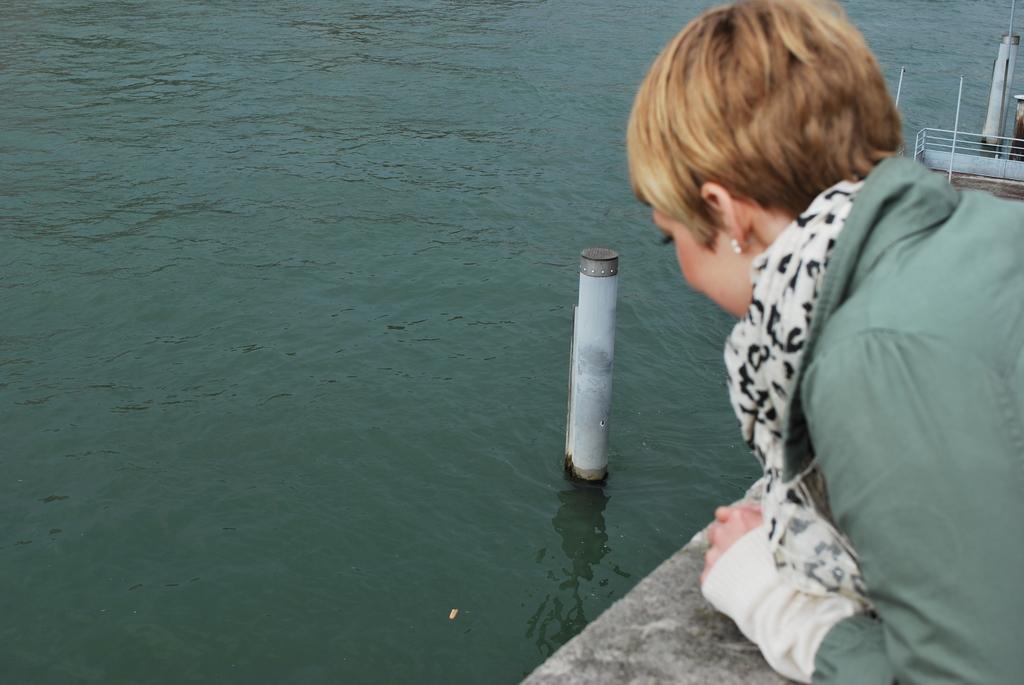How would you summarize this image in a sentence or two? In this image on the right side there is one woman who is standing, and at the bottom there is a river. And in the background there are some poles, and in the center there is one iron rod. 